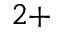<formula> <loc_0><loc_0><loc_500><loc_500>^ { 2 + }</formula> 